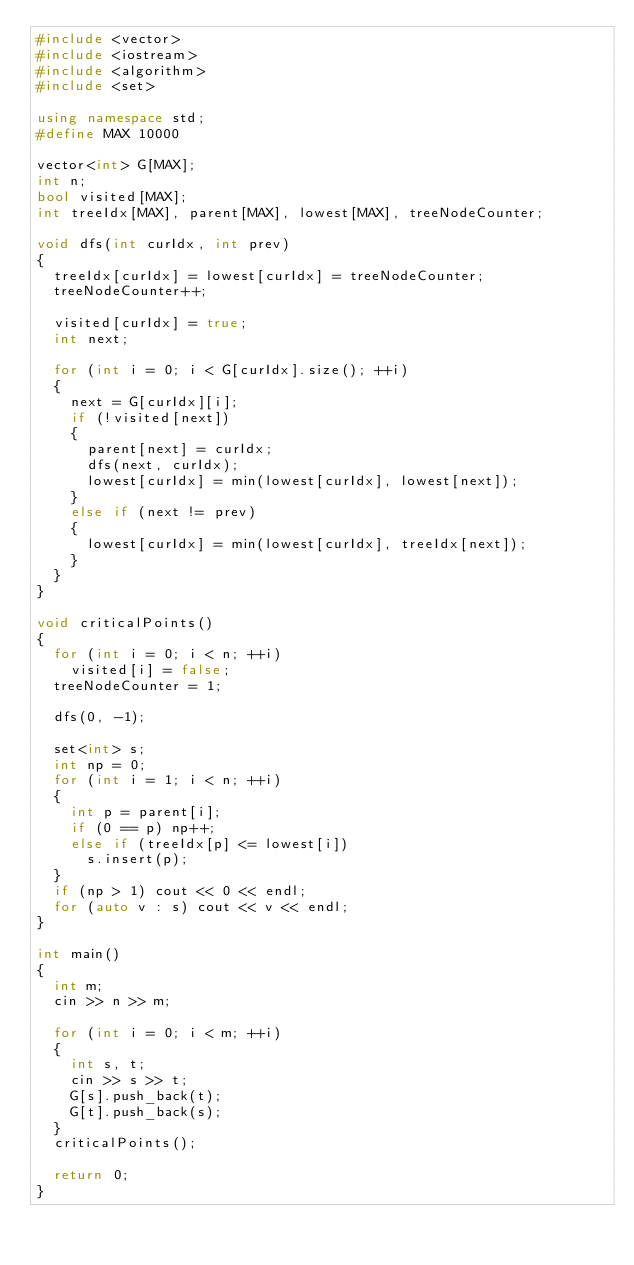Convert code to text. <code><loc_0><loc_0><loc_500><loc_500><_C++_>#include <vector>
#include <iostream>
#include <algorithm>
#include <set>

using namespace std;
#define MAX 10000

vector<int> G[MAX];
int n;
bool visited[MAX];
int treeIdx[MAX], parent[MAX], lowest[MAX], treeNodeCounter;

void dfs(int curIdx, int prev)
{
	treeIdx[curIdx] = lowest[curIdx] = treeNodeCounter;
	treeNodeCounter++;

	visited[curIdx] = true;
	int next;

	for (int i = 0; i < G[curIdx].size(); ++i)
	{
		next = G[curIdx][i];
		if (!visited[next])
		{
			parent[next] = curIdx;
			dfs(next, curIdx);
			lowest[curIdx] = min(lowest[curIdx], lowest[next]);
		}
		else if (next != prev)
		{
			lowest[curIdx] = min(lowest[curIdx], treeIdx[next]);
		}
	}
}

void criticalPoints()
{
	for (int i = 0; i < n; ++i)
		visited[i] = false;
	treeNodeCounter = 1;

	dfs(0, -1);

	set<int> s;
	int np = 0;
	for (int i = 1; i < n; ++i)
	{
		int p = parent[i];
		if (0 == p) np++;
		else if (treeIdx[p] <= lowest[i])
			s.insert(p);
	}
	if (np > 1) cout << 0 << endl;
	for (auto v : s) cout << v << endl;
}

int main()
{
	int m;
	cin >> n >> m;

	for (int i = 0; i < m; ++i)
	{
		int s, t;
		cin >> s >> t;
		G[s].push_back(t);
		G[t].push_back(s);
	}
	criticalPoints();

	return 0;
}</code> 